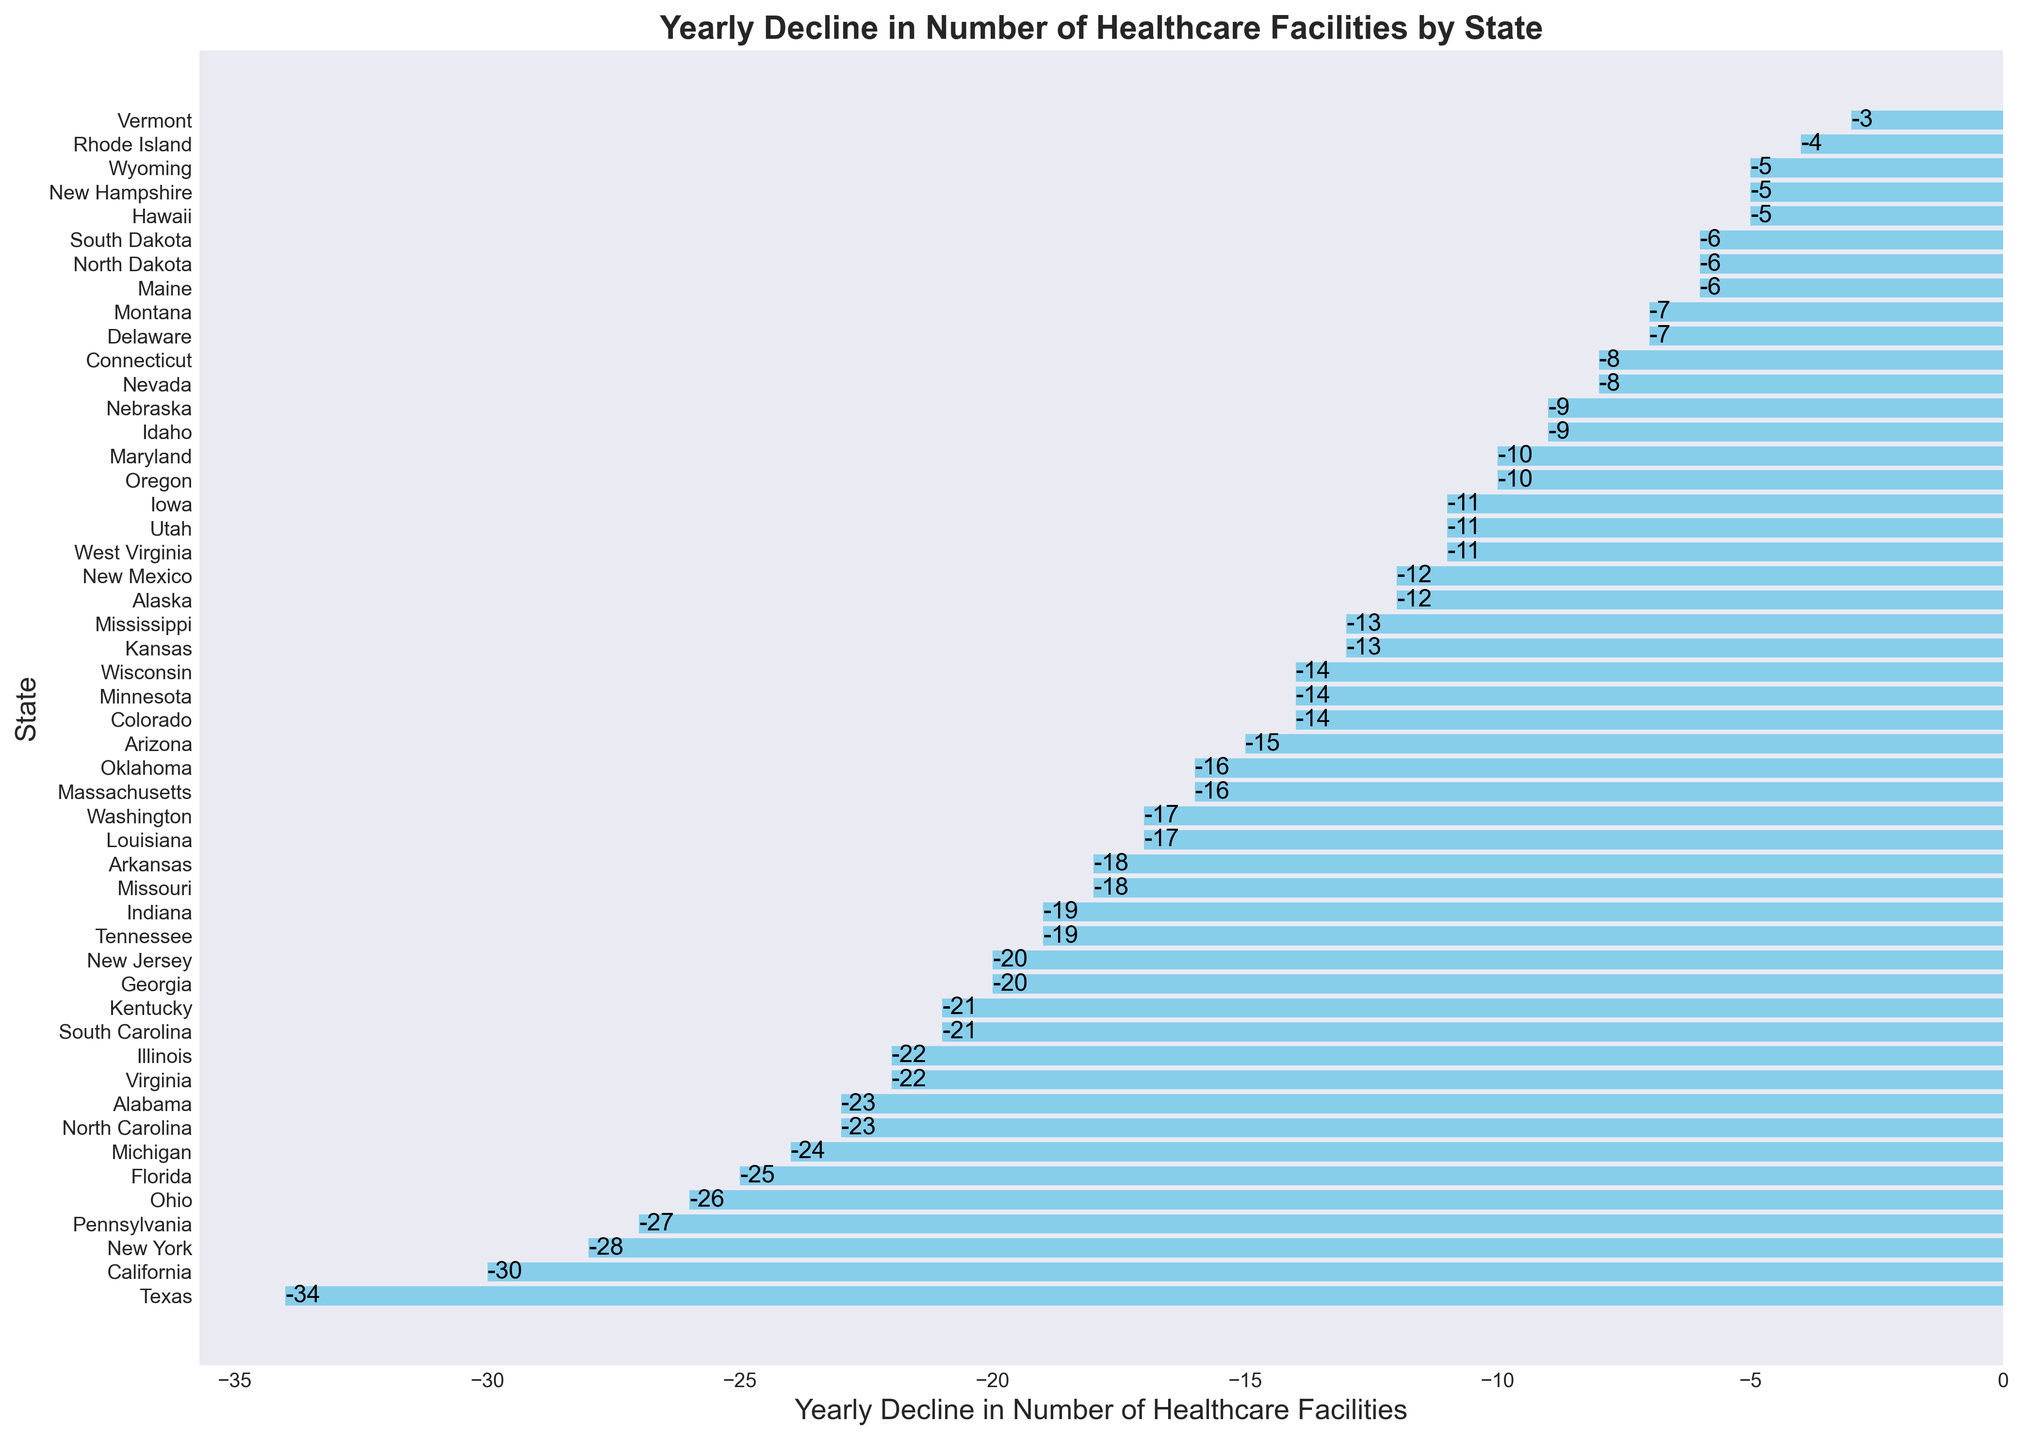What's the state with the largest yearly decline in healthcare facilities? To find the state with the largest yearly decline, look for the bar that extends the furthest left. In this case, it is Texas with a decline of -34 facilities.
Answer: Texas Which states have a yearly decline of exactly -19 facilities? Identify the bars that are aligned with the -19 tick mark on the x-axis. These states are Indiana and Tennessee.
Answer: Indiana, Tennessee What is the average yearly decline of healthcare facilities in California, New York, and Florida? Find the values for California (-30), New York (-28), and Florida (-25), sum them up (-30 + -28 + -25 = -83), then divide by the number of states (3). -83/3 = -27.67.
Answer: -27.67 Which states have a decline greater than -15 but less than -10 facilities per year? Identify the bars that fall between the -15 and -10 tick marks on the x-axis. These states are Idaho (-9) and Maryland (-10).
Answer: Idaho, Maryland What is the difference in yearly decline between Ohio and Pennsylvania? Find the decline for Ohio (-26) and Pennsylvania (-27) and subtract one from the other. -26 - (-27) = 1.
Answer: 1 Which states have a decline less than -5 facilities per year? Locate the bars that extend less than the -5 tick mark on the x-axis. These states are Rhode Island (-4) and Vermont (-3).
Answer: Rhode Island, Vermont How many states have a yearly decline greater than -20 facilities? Count the number of bars that extend left of the -20 tick mark on the x-axis. States with a decline greater than -20 facilities are Texas, California, New York, Michigan, Florida, Ohio, Pennsylvania, Georgia, and New Jersey. This makes a total of 9 states.
Answer: 9 Which state has the smallest yearly decline in healthcare facilities? The smallest decline is identified by the bar that extends the least amount to the left. Rhode Island has the smallest decline of -4 facilities.
Answer: Rhode Island What's the total yearly decline of healthcare facilities for the states in the Southeastern region (including Alabama, Florida, Georgia, Kentucky, Mississippi, North Carolina, South Carolina, Tennessee, Virginia, and West Virginia)? Find the values for each Southeastern state: Alabama (-23), Florida (-25), Georgia (-20), Kentucky (-21), Mississippi (-13), North Carolina (-23), South Carolina (-21), Tennessee (-19), Virginia (-22), and West Virginia (-11). Sum these values: -23 + -25 + -20 + -21 + -13 + -23 + -21 + -19 + -22 + -11 = -198.
Answer: -198 